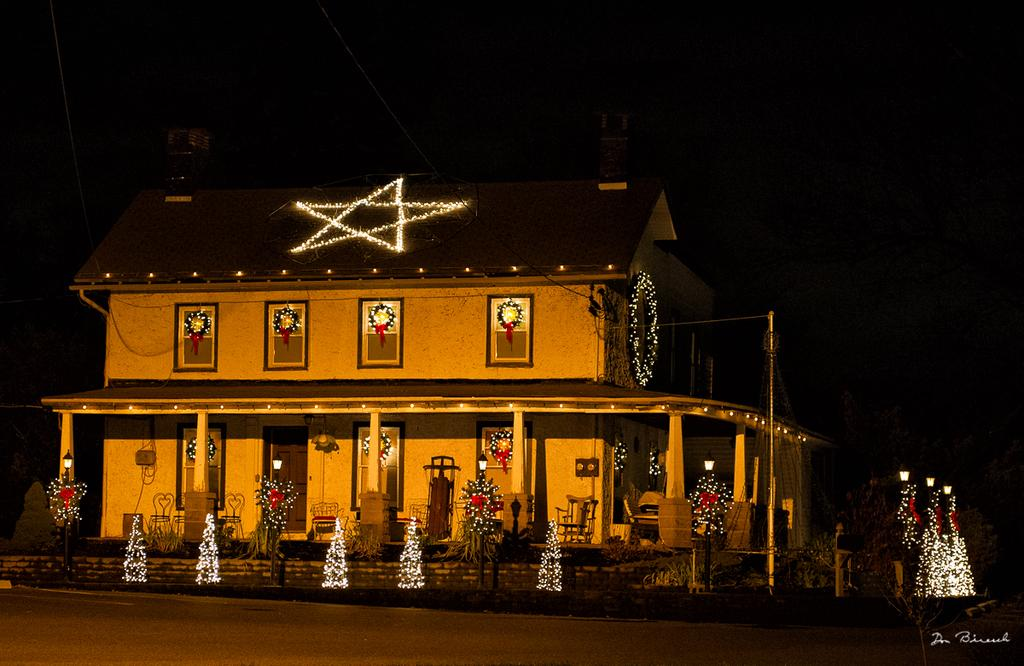What type of structure is visible in the image? There is a house in the image. Are there any specific features on the house? Yes, there are lights on the house. What else can be seen in the image besides the house? There are plants visible in the image. How would you describe the overall appearance of the image? The background of the image is dark. How many cows can be seen grazing in the image? There are no cows present in the image. What type of juice is being served in the image? There is no juice present in the image. 